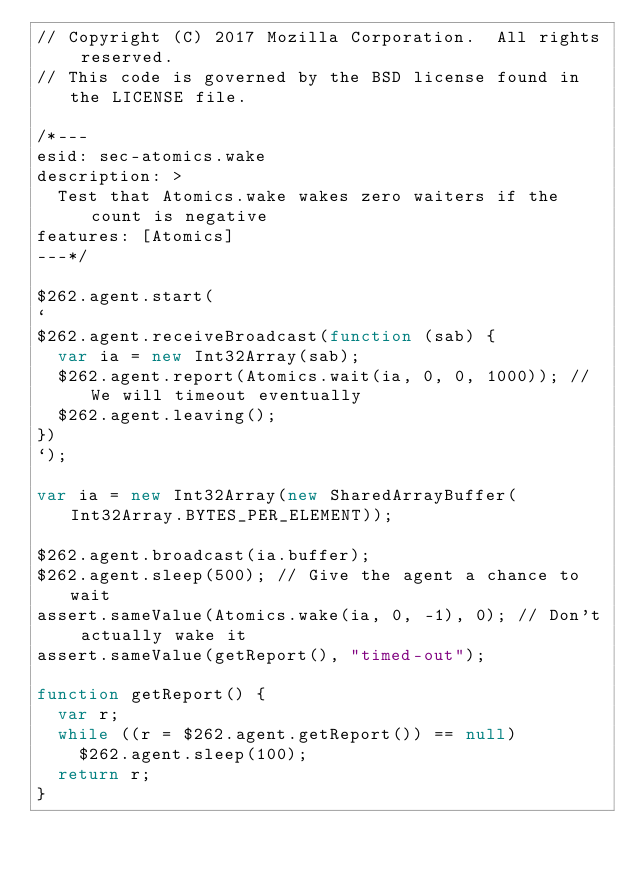Convert code to text. <code><loc_0><loc_0><loc_500><loc_500><_JavaScript_>// Copyright (C) 2017 Mozilla Corporation.  All rights reserved.
// This code is governed by the BSD license found in the LICENSE file.

/*---
esid: sec-atomics.wake
description: >
  Test that Atomics.wake wakes zero waiters if the count is negative
features: [Atomics]
---*/

$262.agent.start(
`
$262.agent.receiveBroadcast(function (sab) {
  var ia = new Int32Array(sab);
  $262.agent.report(Atomics.wait(ia, 0, 0, 1000)); // We will timeout eventually
  $262.agent.leaving();
})
`);

var ia = new Int32Array(new SharedArrayBuffer(Int32Array.BYTES_PER_ELEMENT));

$262.agent.broadcast(ia.buffer);
$262.agent.sleep(500); // Give the agent a chance to wait
assert.sameValue(Atomics.wake(ia, 0, -1), 0); // Don't actually wake it
assert.sameValue(getReport(), "timed-out");

function getReport() {
  var r;
  while ((r = $262.agent.getReport()) == null)
    $262.agent.sleep(100);
  return r;
}
</code> 